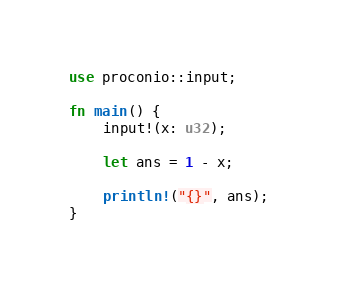Convert code to text. <code><loc_0><loc_0><loc_500><loc_500><_Rust_>use proconio::input;

fn main() {
    input!(x: u32);

    let ans = 1 - x;

    println!("{}", ans);
}
</code> 